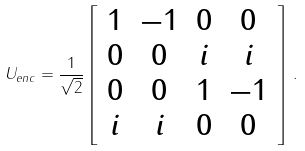Convert formula to latex. <formula><loc_0><loc_0><loc_500><loc_500>U _ { e n c } = \frac { 1 } { \sqrt { 2 } } \left [ \begin{array} { c c c c } { 1 } & { - 1 } & { 0 } & { 0 } \\ { 0 } & { 0 } & { i } & { i } \\ { 0 } & { 0 } & { 1 } & { - 1 } \\ { i } & { i } & { 0 } & { 0 } \end{array} \right ] \, .</formula> 